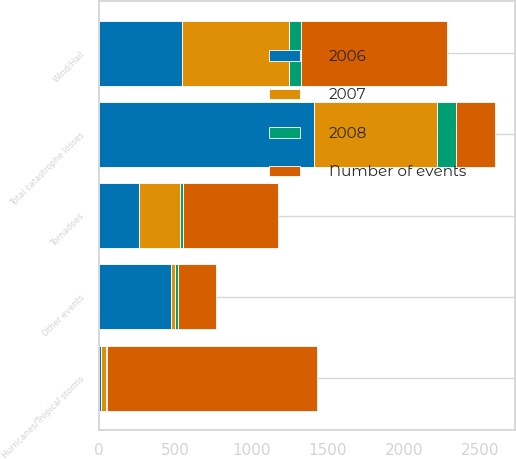Convert chart to OTSL. <chart><loc_0><loc_0><loc_500><loc_500><stacked_bar_chart><ecel><fcel>Hurricanes/Tropical storms<fcel>Tornadoes<fcel>Wind/Hail<fcel>Other events<fcel>Total catastrophe losses<nl><fcel>Number of events<fcel>1381<fcel>628<fcel>960<fcel>248<fcel>258<nl><fcel>2008<fcel>5<fcel>19<fcel>81<fcel>18<fcel>123<nl><fcel>2006<fcel>9<fcel>258<fcel>542<fcel>473<fcel>1409<nl><fcel>2007<fcel>36<fcel>271<fcel>702<fcel>24<fcel>810<nl></chart> 